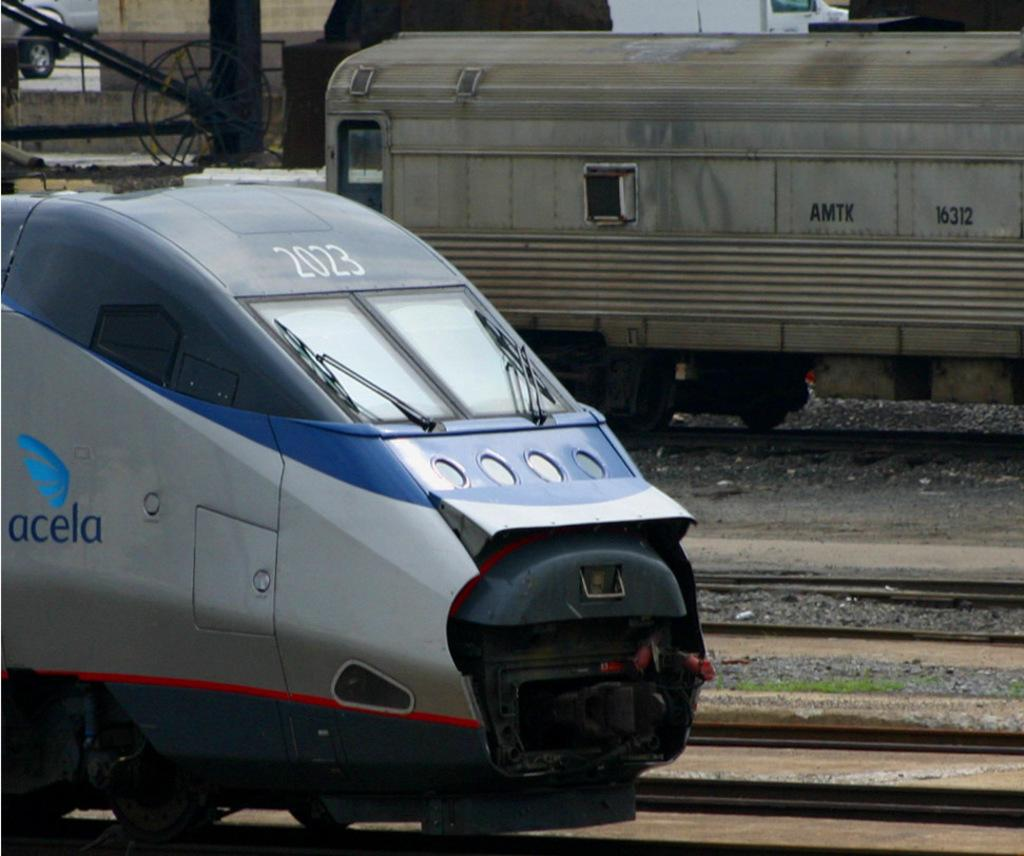What is the main subject of the image? The main subject of the image is a train engine. What is the train engine doing in the image? The train engine is moving on a track. What else can be seen behind the train engine? There is another object behind the train engine. What type of structure is present in the image? There is a building in the image. What are the poles used for in the image? The poles are likely used for supporting wires or other infrastructure. What can be seen at the left side of the image? There are vehicles visible at the left side of the image. How much payment is required to ride the tramp in the image? There is no tramp present in the image; it features a train engine moving on a track. What type of creature is hiding in the cellar in the image? There is no cellar present in the image, and therefore no creature can be found hiding in it. 